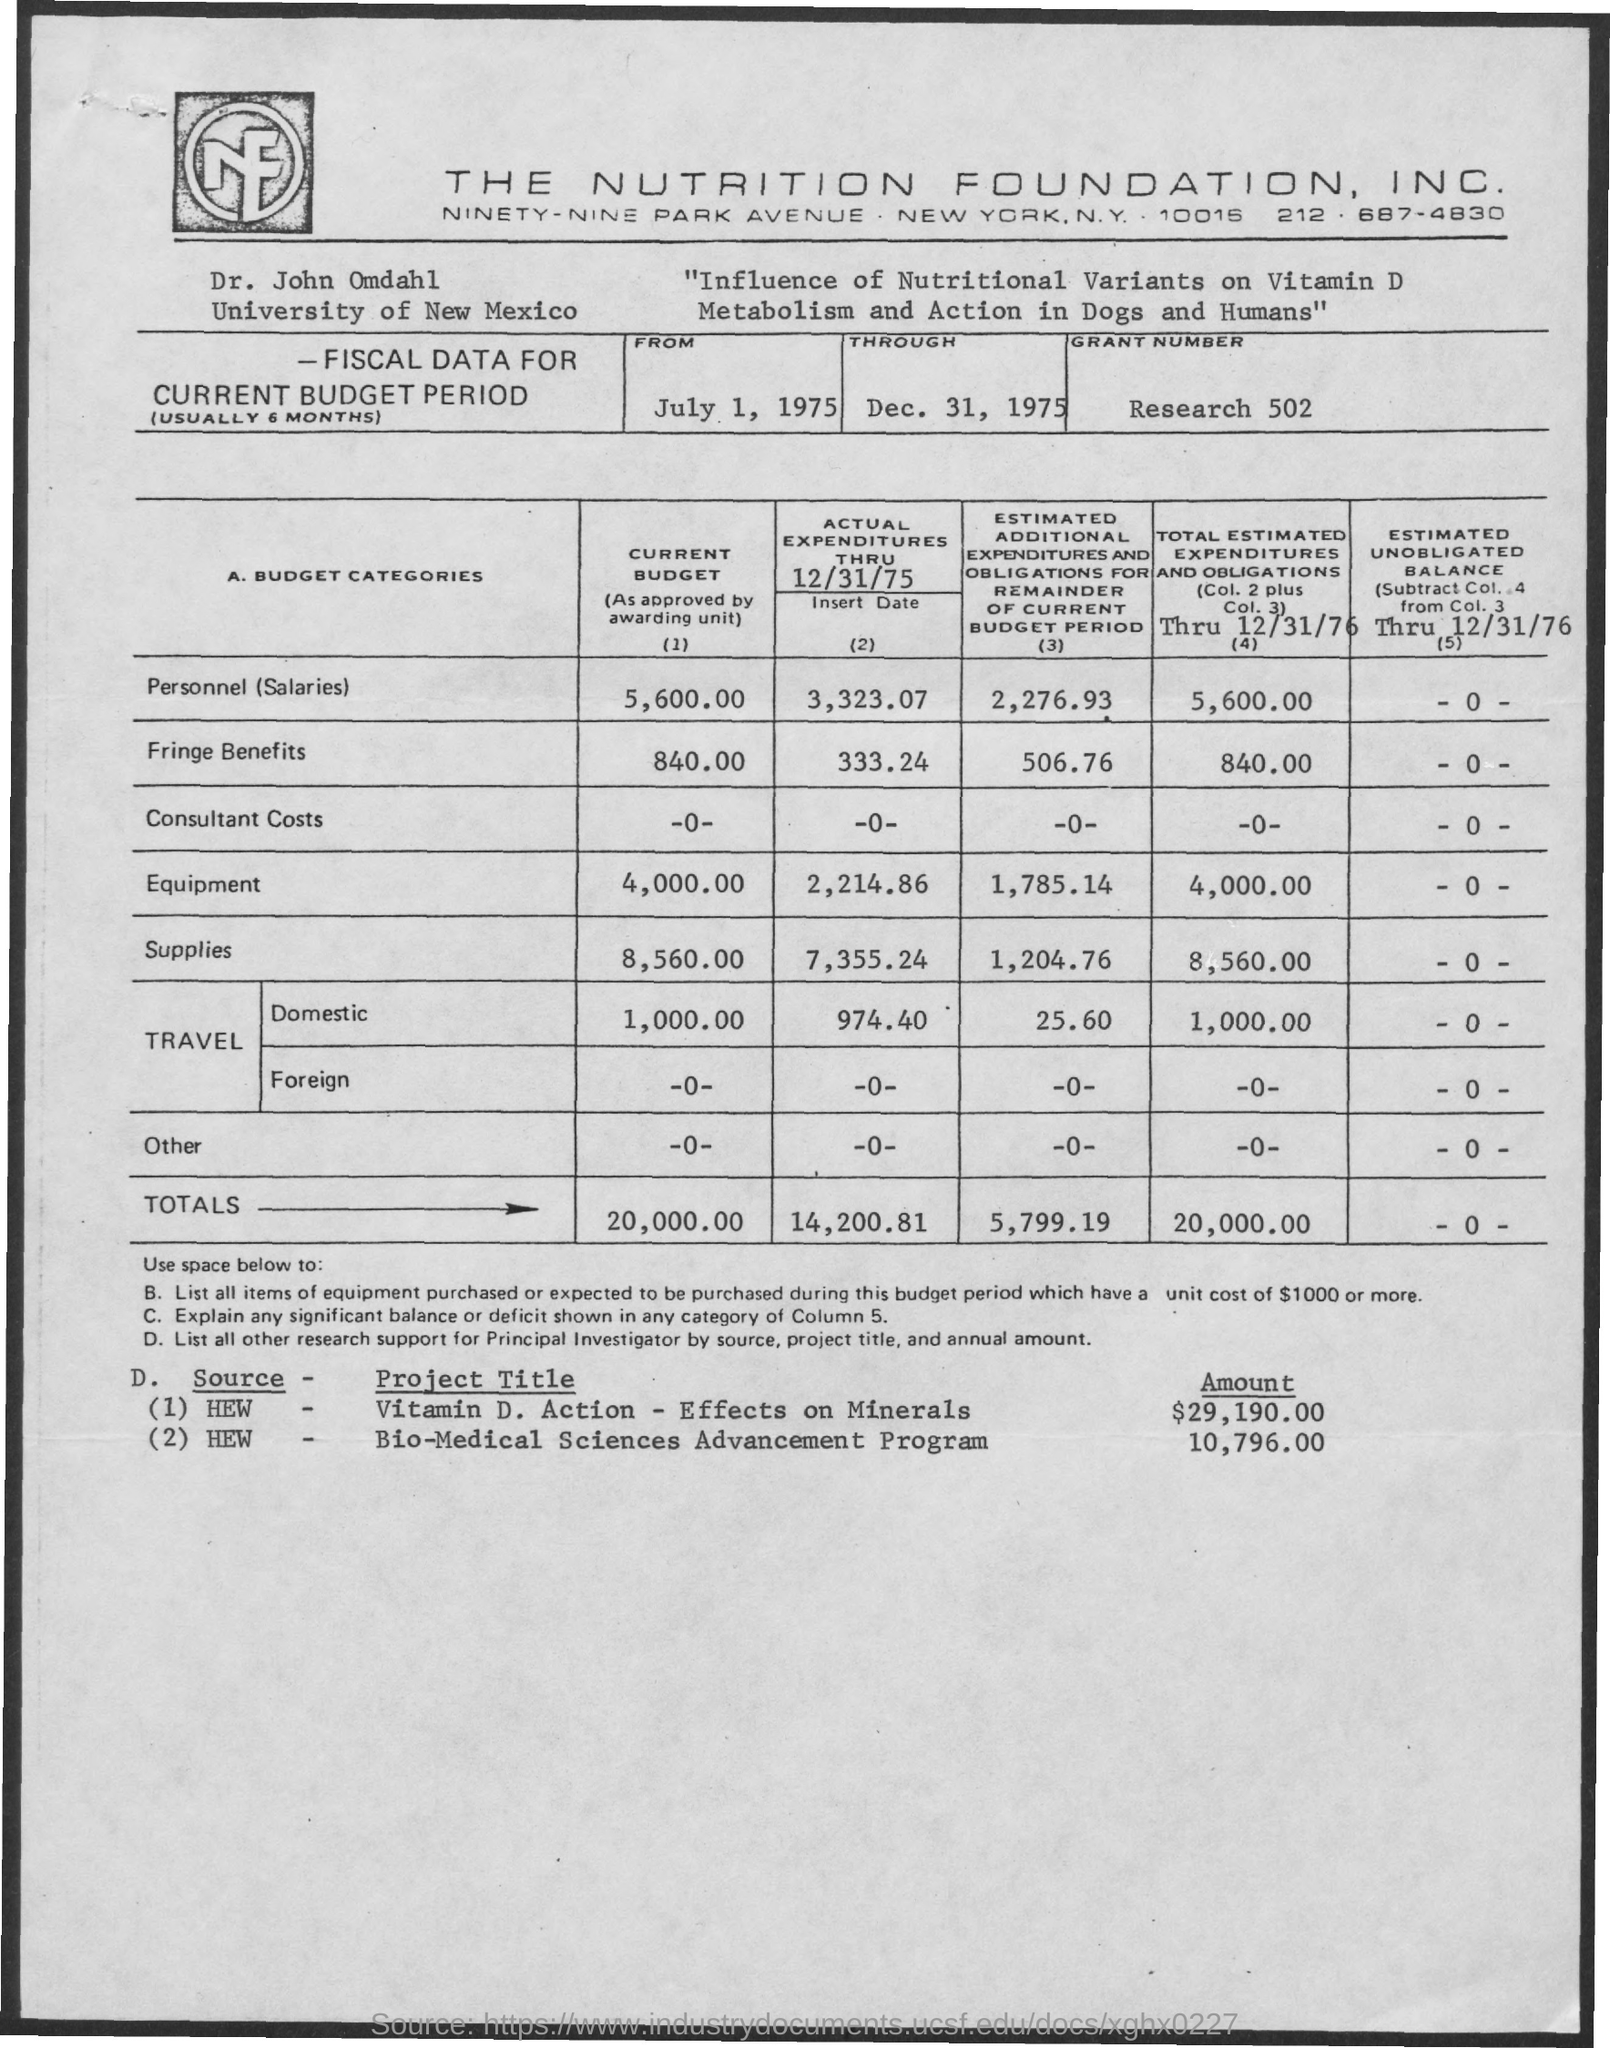Identify some key points in this picture. Dr. John Omdahl is affiliated with the University of New Mexico. I hereby declare that the top firm mentioned on the page is THE NUTRITION FOUNDATION, INC... The research aims to investigate the impact of nutritional variants on the metabolism and action of vitamin D in both dogs and humans. Dr. John Omdahl is the researcher. The grant number for the research is 502. 